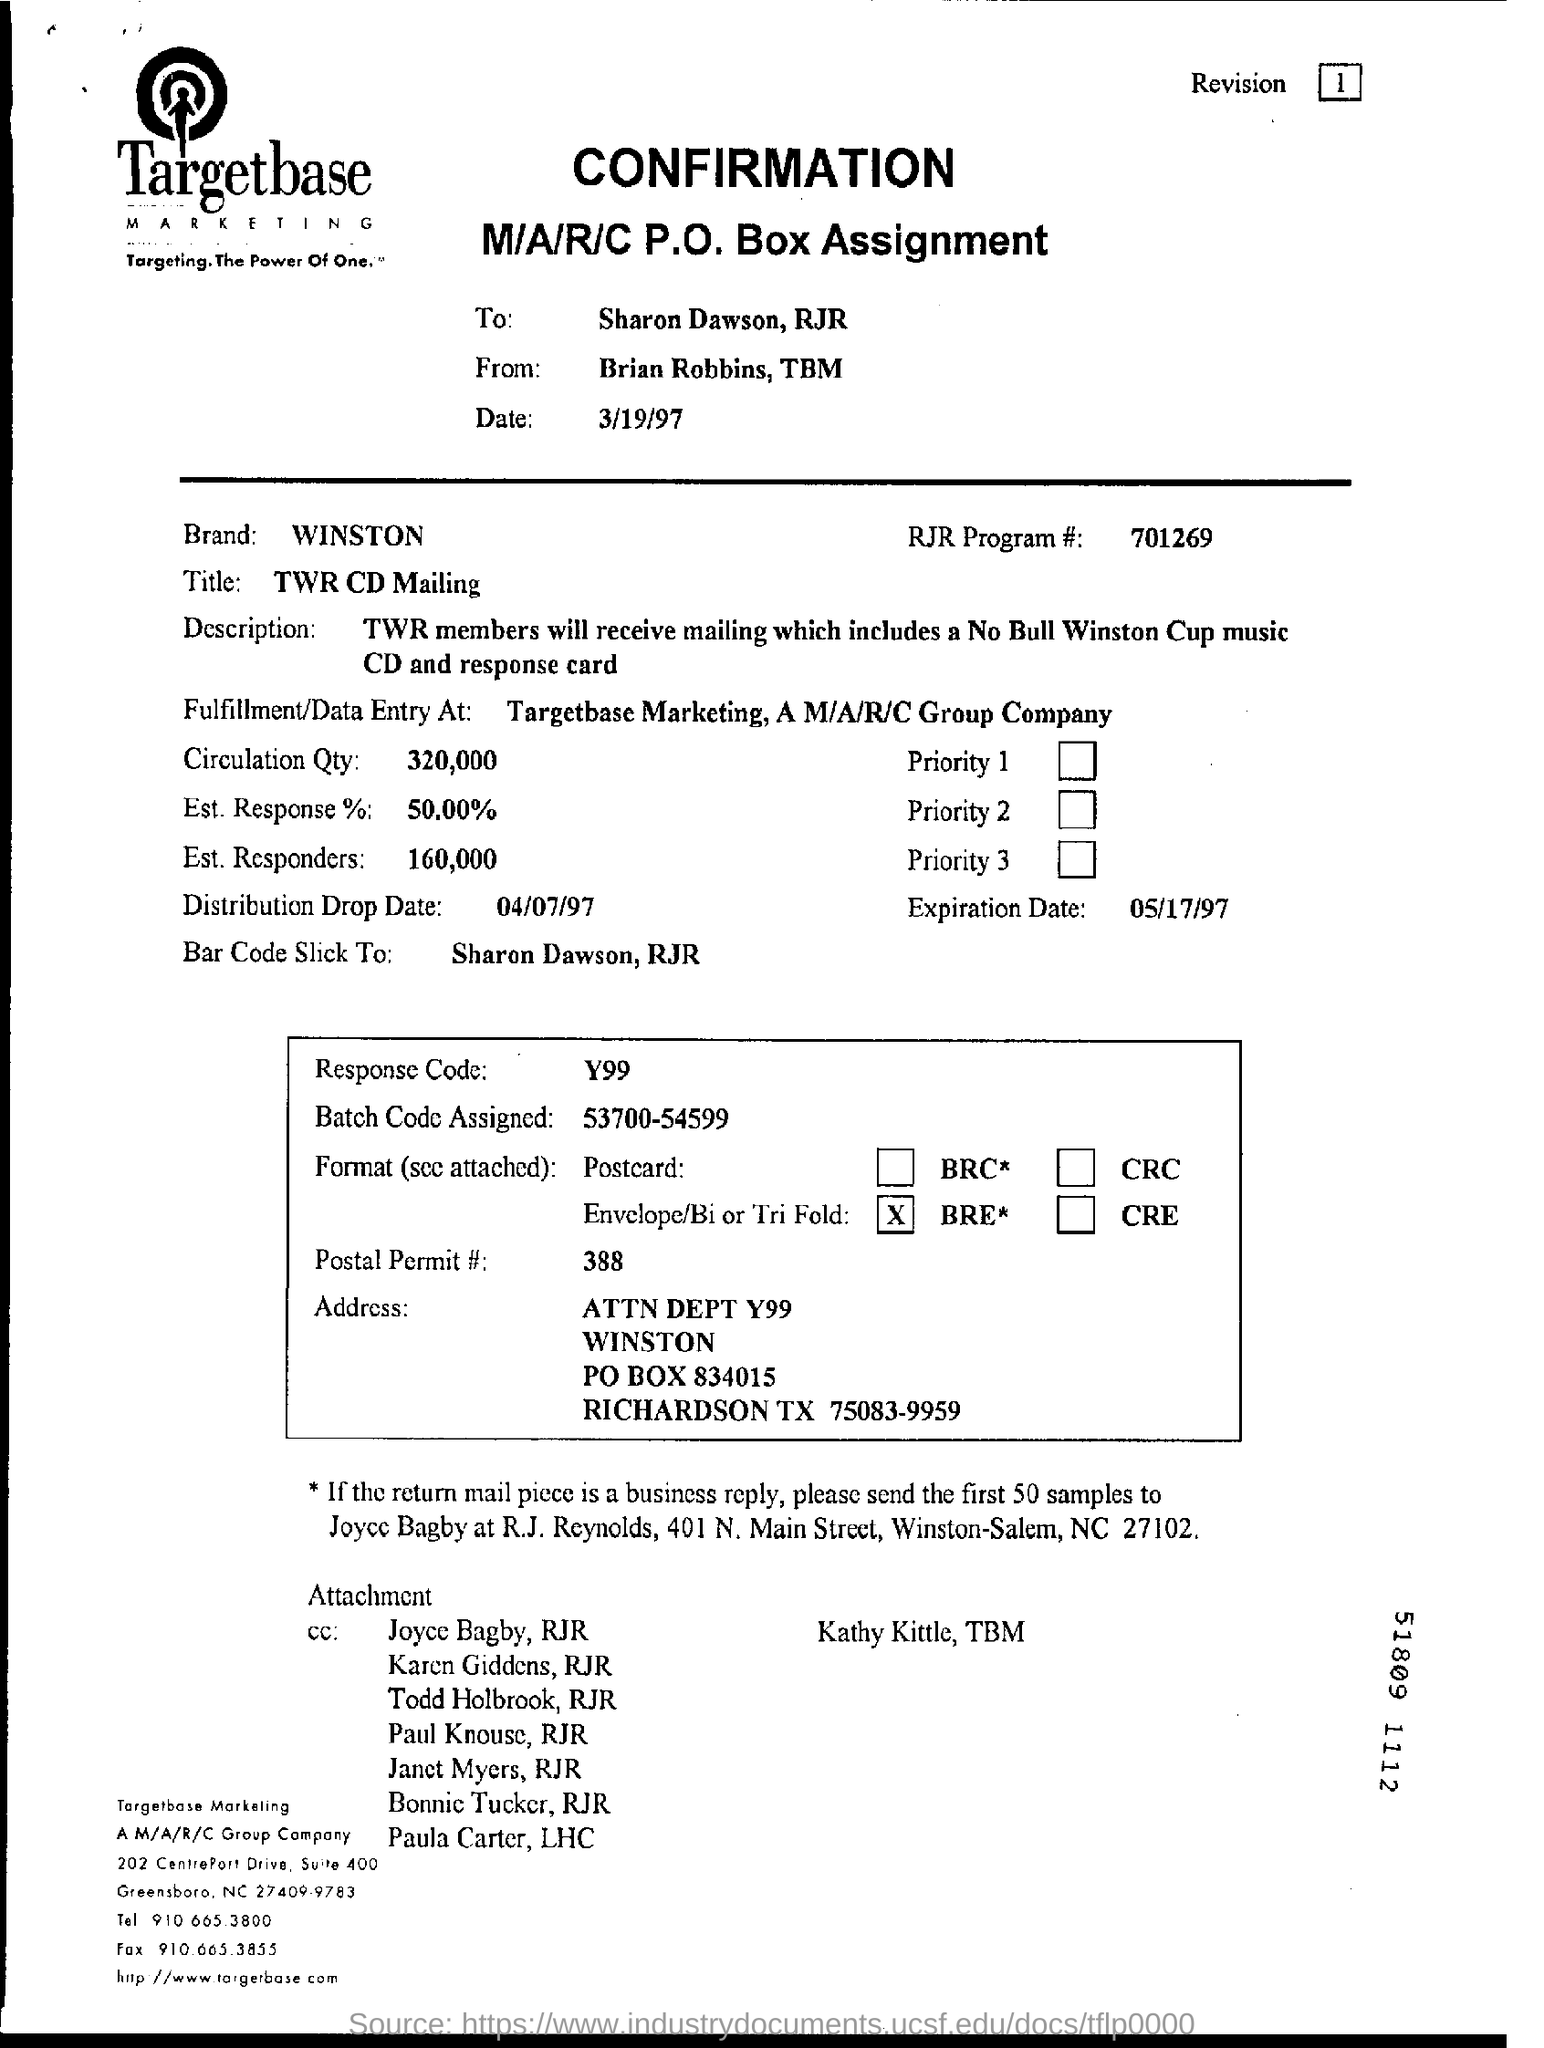Specify some key components in this picture. The number of estimated responders mentioned is 160,000. The brand name is Winston. The expiration date is May 17, 1997. The distribution drop date is April 7th, 1997. 